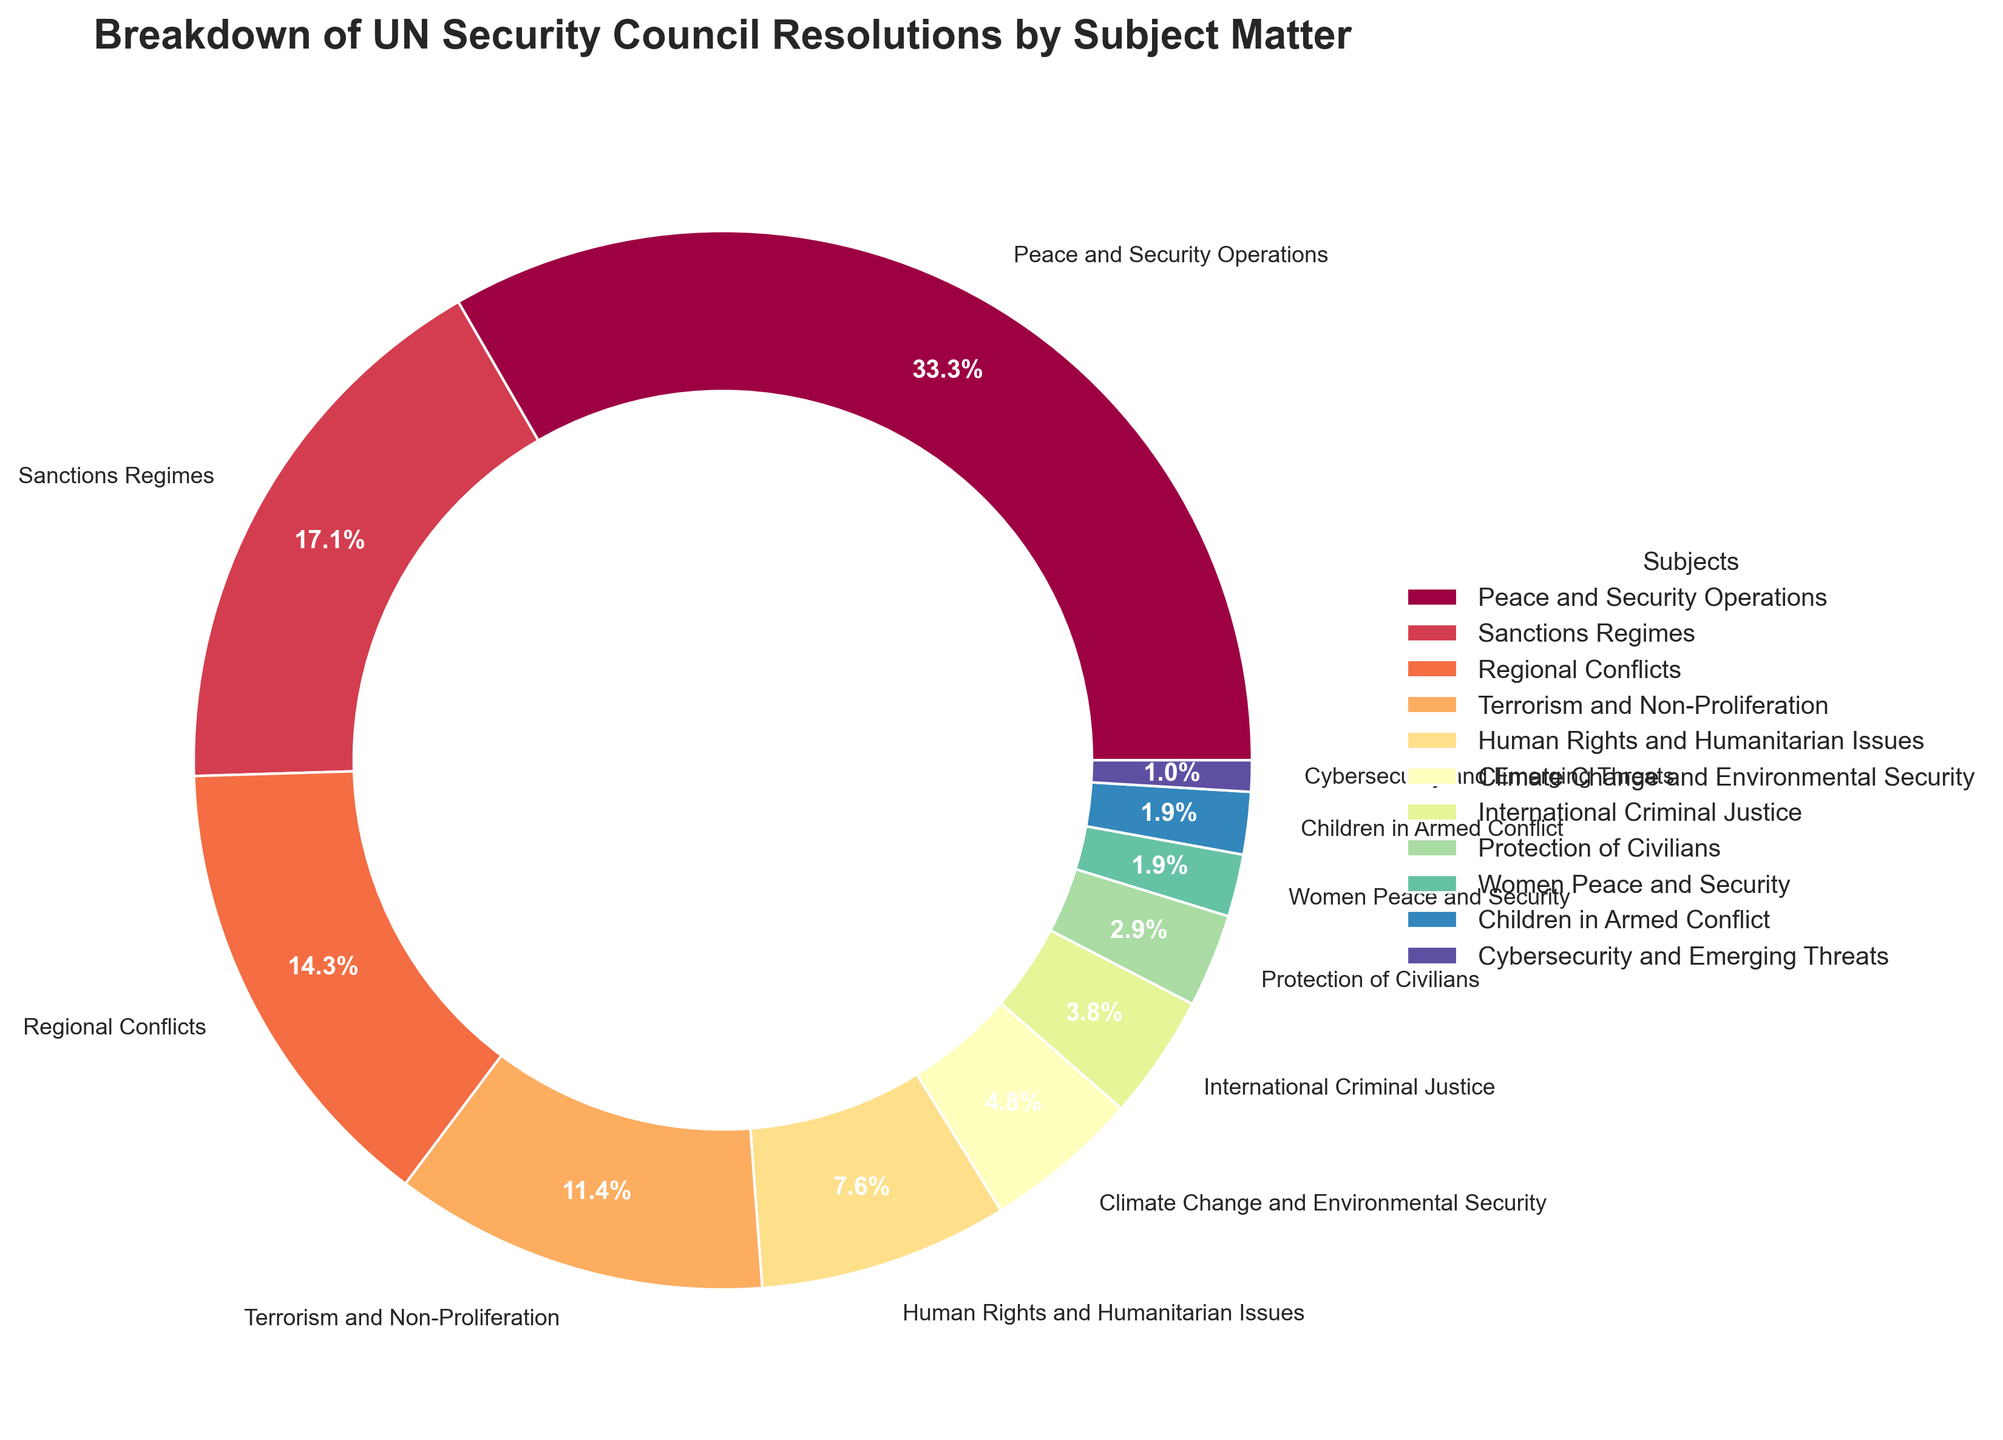Which subject has the highest percentage of UN Security Council resolutions? Identify the segment with the largest percentage. "Peace and Security Operations" has the largest segment with 35%.
Answer: Peace and Security Operations Which subject has the smallest percentage of UN Security Council resolutions? Identify the segment with the smallest percentage. "Cybersecurity and Emerging Threats" has the smallest segment with 1%.
Answer: Cybersecurity and Emerging Threats What is the combined percentage of resolutions for "Regional Conflicts" and "Sanctions Regimes"? Add the percentages for "Regional Conflicts" (15%) and "Sanctions Regimes" (18%). 15% + 18% = 33%.
Answer: 33% Are there more resolutions focused on "Human Rights and Humanitarian Issues" or "Climate Change and Environmental Security"? Compare the percentages for "Human Rights and Humanitarian Issues" (8%) and "Climate Change and Environmental Security" (5%). 8% > 5%.
Answer: Human Rights and Humanitarian Issues What is the percentage difference between "Terrorism and Non-Proliferation" and "International Criminal Justice"? Calculate the difference in percentages: "Terrorism and Non-Proliferation" (12%) and "International Criminal Justice" (4%). 12% - 4% = 8%.
Answer: 8% Which subjects have a percentage below 5%? Identify all subjects with percentages less than 5%. "International Criminal Justice" (4%), "Protection of Civilians" (3%), "Women Peace and Security" (2%), "Children in Armed Conflict" (2%), and "Cybersecurity and Emerging Threats" (1%).
Answer: International Criminal Justice, Protection of Civilians, Women Peace and Security, Children in Armed Conflict, Cybersecurity and Emerging Threats What is the total percentage of resolutions that are not related to "Peace and Security Operations"? Subtract the percentage of "Peace and Security Operations" from 100%. 100% - 35% = 65%.
Answer: 65% Which two subjects together make up nearly half of the resolutions? Identify the subjects whose combined percentage is closest to 50%. "Peace and Security Operations" (35%) and "Sanctions Regimes" (18%). 35% + 18% = 53%.
Answer: Peace and Security Operations and Sanctions Regimes What is the average percentage of the resolutions concerning "Women Peace and Security", "Children in Armed Conflict", and "Cybersecurity and Emerging Threats"? Calculate the average of the percentages of the three subjects: (2% + 2% + 1%) / 3 = 5% / 3 = 1.67%.
Answer: 1.67% 